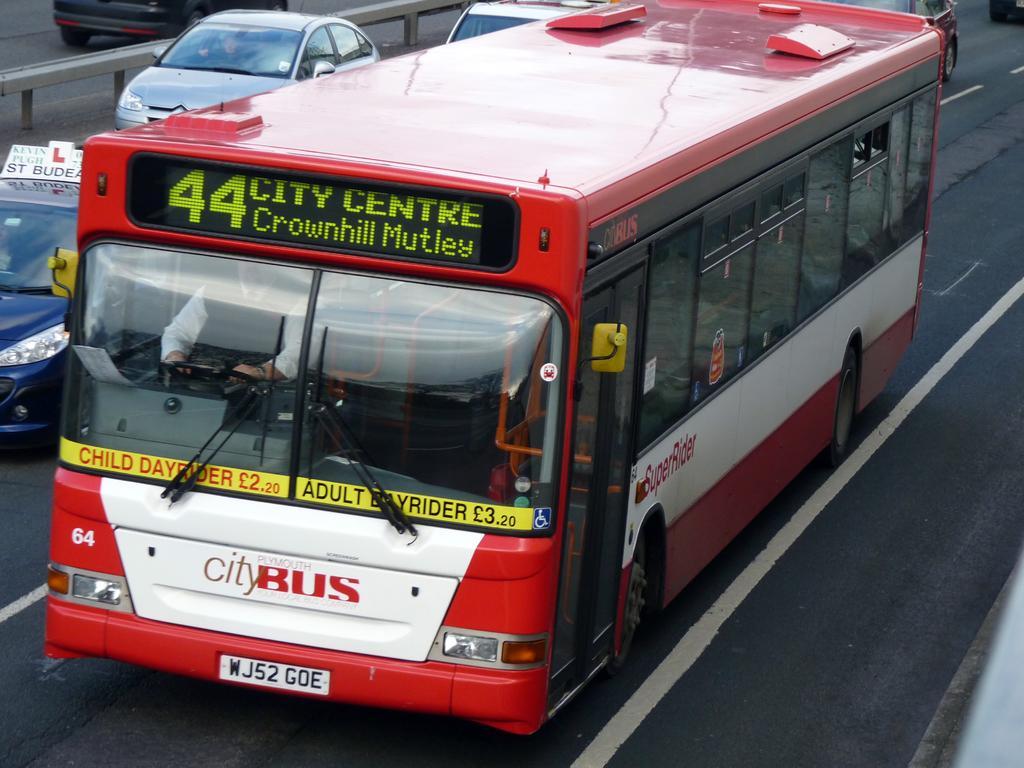Please provide a concise description of this image. In the foreground of this picture, there is a red color bus moving on the road. In the background, there are vehicles and a divider. 